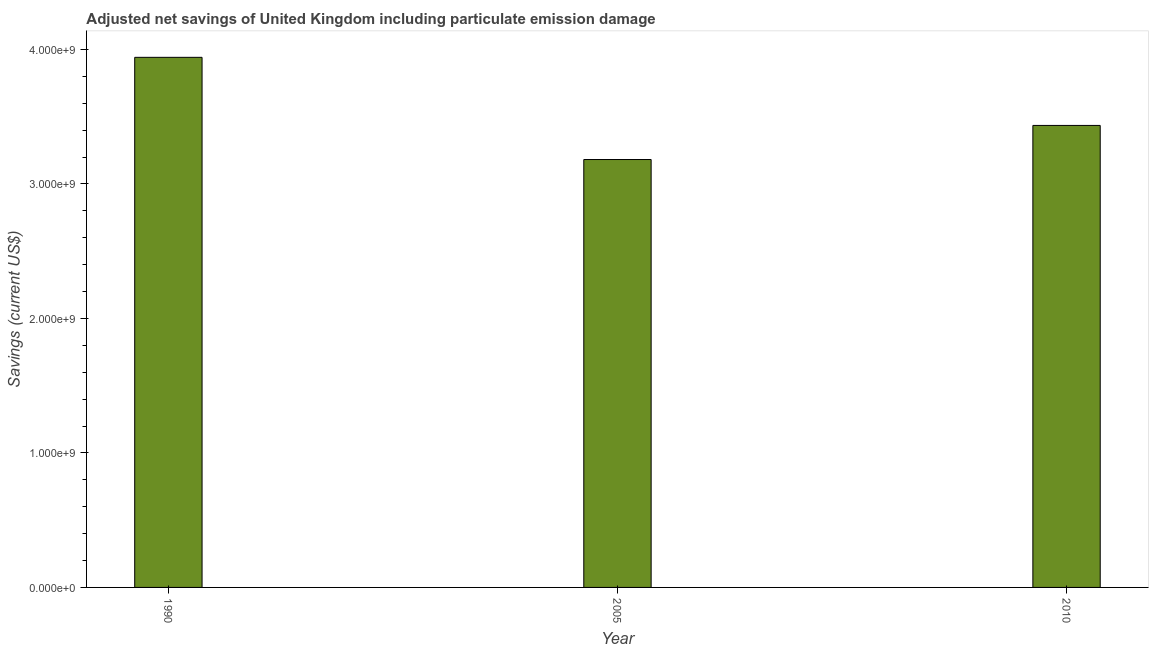What is the title of the graph?
Your answer should be very brief. Adjusted net savings of United Kingdom including particulate emission damage. What is the label or title of the Y-axis?
Give a very brief answer. Savings (current US$). What is the adjusted net savings in 2005?
Ensure brevity in your answer.  3.18e+09. Across all years, what is the maximum adjusted net savings?
Offer a terse response. 3.94e+09. Across all years, what is the minimum adjusted net savings?
Give a very brief answer. 3.18e+09. In which year was the adjusted net savings maximum?
Provide a succinct answer. 1990. In which year was the adjusted net savings minimum?
Offer a very short reply. 2005. What is the sum of the adjusted net savings?
Offer a very short reply. 1.06e+1. What is the difference between the adjusted net savings in 2005 and 2010?
Your response must be concise. -2.53e+08. What is the average adjusted net savings per year?
Your response must be concise. 3.52e+09. What is the median adjusted net savings?
Keep it short and to the point. 3.43e+09. What is the ratio of the adjusted net savings in 1990 to that in 2010?
Give a very brief answer. 1.15. Is the adjusted net savings in 2005 less than that in 2010?
Your answer should be compact. Yes. What is the difference between the highest and the second highest adjusted net savings?
Ensure brevity in your answer.  5.06e+08. What is the difference between the highest and the lowest adjusted net savings?
Offer a very short reply. 7.60e+08. How many bars are there?
Offer a very short reply. 3. Are all the bars in the graph horizontal?
Your answer should be compact. No. How many years are there in the graph?
Keep it short and to the point. 3. What is the difference between two consecutive major ticks on the Y-axis?
Give a very brief answer. 1.00e+09. What is the Savings (current US$) in 1990?
Provide a succinct answer. 3.94e+09. What is the Savings (current US$) in 2005?
Your response must be concise. 3.18e+09. What is the Savings (current US$) in 2010?
Provide a succinct answer. 3.43e+09. What is the difference between the Savings (current US$) in 1990 and 2005?
Offer a terse response. 7.60e+08. What is the difference between the Savings (current US$) in 1990 and 2010?
Give a very brief answer. 5.06e+08. What is the difference between the Savings (current US$) in 2005 and 2010?
Your answer should be very brief. -2.53e+08. What is the ratio of the Savings (current US$) in 1990 to that in 2005?
Your response must be concise. 1.24. What is the ratio of the Savings (current US$) in 1990 to that in 2010?
Give a very brief answer. 1.15. What is the ratio of the Savings (current US$) in 2005 to that in 2010?
Provide a short and direct response. 0.93. 